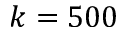Convert formula to latex. <formula><loc_0><loc_0><loc_500><loc_500>k = 5 0 0</formula> 